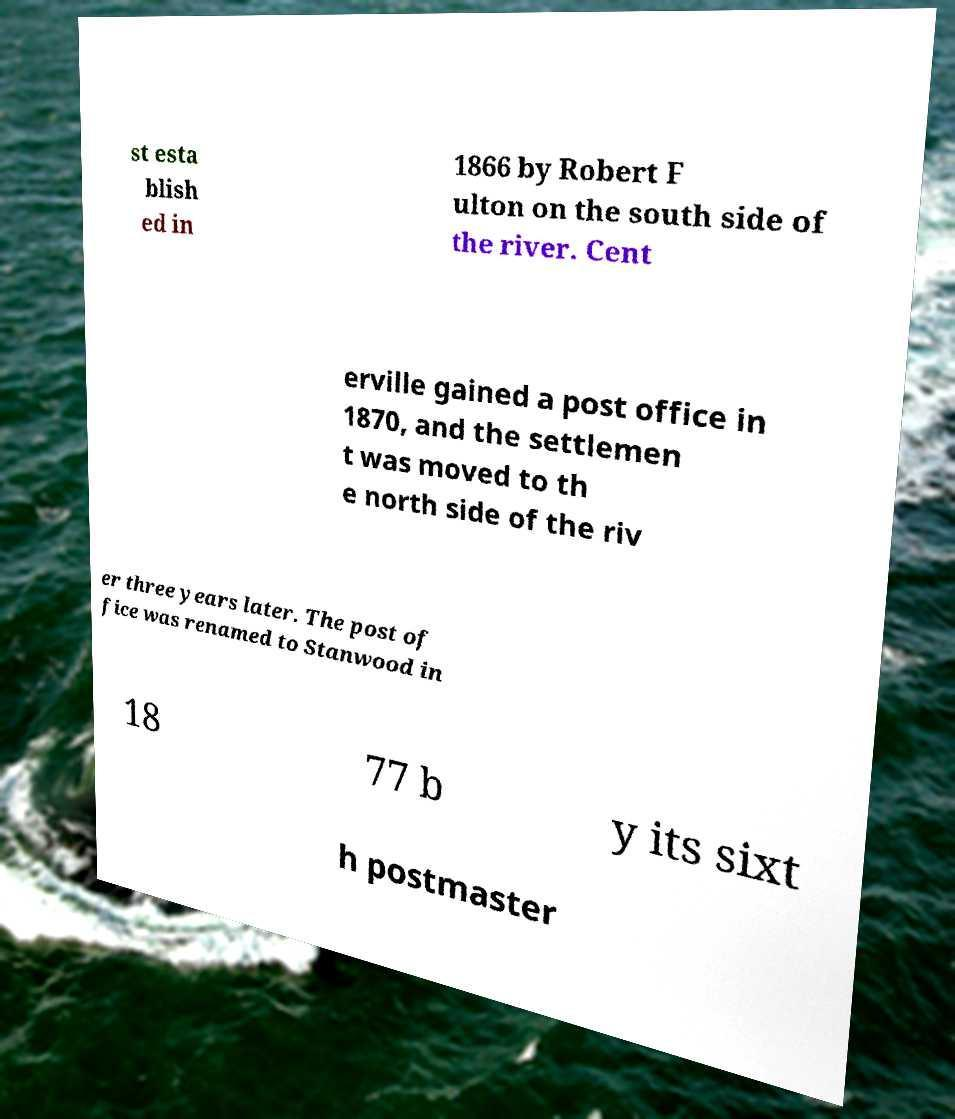There's text embedded in this image that I need extracted. Can you transcribe it verbatim? st esta blish ed in 1866 by Robert F ulton on the south side of the river. Cent erville gained a post office in 1870, and the settlemen t was moved to th e north side of the riv er three years later. The post of fice was renamed to Stanwood in 18 77 b y its sixt h postmaster 